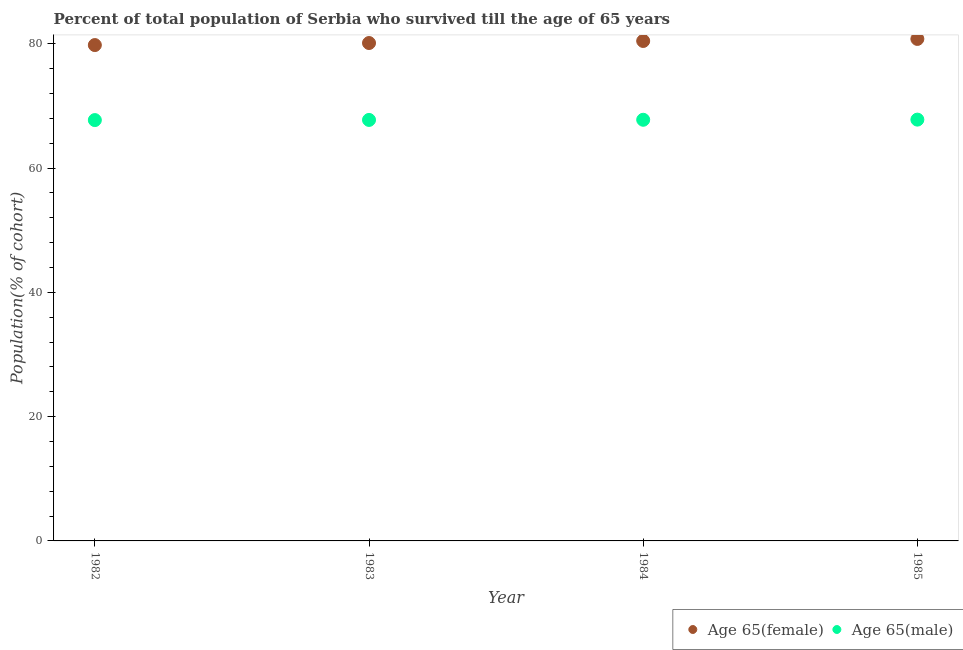What is the percentage of female population who survived till age of 65 in 1985?
Keep it short and to the point. 80.77. Across all years, what is the maximum percentage of male population who survived till age of 65?
Give a very brief answer. 67.79. Across all years, what is the minimum percentage of female population who survived till age of 65?
Your answer should be very brief. 79.78. What is the total percentage of male population who survived till age of 65 in the graph?
Your answer should be very brief. 271. What is the difference between the percentage of female population who survived till age of 65 in 1983 and that in 1985?
Offer a very short reply. -0.66. What is the difference between the percentage of female population who survived till age of 65 in 1982 and the percentage of male population who survived till age of 65 in 1984?
Ensure brevity in your answer.  12.02. What is the average percentage of female population who survived till age of 65 per year?
Provide a succinct answer. 80.27. In the year 1985, what is the difference between the percentage of male population who survived till age of 65 and percentage of female population who survived till age of 65?
Your answer should be very brief. -12.98. What is the ratio of the percentage of female population who survived till age of 65 in 1982 to that in 1983?
Make the answer very short. 1. Is the percentage of male population who survived till age of 65 in 1982 less than that in 1985?
Keep it short and to the point. Yes. What is the difference between the highest and the second highest percentage of male population who survived till age of 65?
Offer a terse response. 0.02. What is the difference between the highest and the lowest percentage of female population who survived till age of 65?
Give a very brief answer. 0.99. In how many years, is the percentage of male population who survived till age of 65 greater than the average percentage of male population who survived till age of 65 taken over all years?
Offer a very short reply. 2. Is the percentage of female population who survived till age of 65 strictly less than the percentage of male population who survived till age of 65 over the years?
Your response must be concise. No. What is the difference between two consecutive major ticks on the Y-axis?
Your answer should be compact. 20. Are the values on the major ticks of Y-axis written in scientific E-notation?
Provide a succinct answer. No. Does the graph contain grids?
Provide a succinct answer. No. Where does the legend appear in the graph?
Provide a short and direct response. Bottom right. How are the legend labels stacked?
Your response must be concise. Horizontal. What is the title of the graph?
Your answer should be very brief. Percent of total population of Serbia who survived till the age of 65 years. Does "Grants" appear as one of the legend labels in the graph?
Provide a short and direct response. No. What is the label or title of the Y-axis?
Ensure brevity in your answer.  Population(% of cohort). What is the Population(% of cohort) in Age 65(female) in 1982?
Keep it short and to the point. 79.78. What is the Population(% of cohort) of Age 65(male) in 1982?
Offer a terse response. 67.71. What is the Population(% of cohort) of Age 65(female) in 1983?
Provide a short and direct response. 80.11. What is the Population(% of cohort) of Age 65(male) in 1983?
Give a very brief answer. 67.74. What is the Population(% of cohort) of Age 65(female) in 1984?
Ensure brevity in your answer.  80.44. What is the Population(% of cohort) in Age 65(male) in 1984?
Your answer should be very brief. 67.76. What is the Population(% of cohort) of Age 65(female) in 1985?
Your response must be concise. 80.77. What is the Population(% of cohort) in Age 65(male) in 1985?
Provide a short and direct response. 67.79. Across all years, what is the maximum Population(% of cohort) of Age 65(female)?
Provide a succinct answer. 80.77. Across all years, what is the maximum Population(% of cohort) in Age 65(male)?
Provide a short and direct response. 67.79. Across all years, what is the minimum Population(% of cohort) in Age 65(female)?
Give a very brief answer. 79.78. Across all years, what is the minimum Population(% of cohort) in Age 65(male)?
Keep it short and to the point. 67.71. What is the total Population(% of cohort) of Age 65(female) in the graph?
Your response must be concise. 321.1. What is the total Population(% of cohort) of Age 65(male) in the graph?
Keep it short and to the point. 271. What is the difference between the Population(% of cohort) of Age 65(female) in 1982 and that in 1983?
Provide a short and direct response. -0.33. What is the difference between the Population(% of cohort) in Age 65(male) in 1982 and that in 1983?
Offer a terse response. -0.03. What is the difference between the Population(% of cohort) in Age 65(female) in 1982 and that in 1984?
Give a very brief answer. -0.66. What is the difference between the Population(% of cohort) of Age 65(male) in 1982 and that in 1984?
Make the answer very short. -0.05. What is the difference between the Population(% of cohort) in Age 65(female) in 1982 and that in 1985?
Keep it short and to the point. -0.99. What is the difference between the Population(% of cohort) of Age 65(male) in 1982 and that in 1985?
Your response must be concise. -0.07. What is the difference between the Population(% of cohort) of Age 65(female) in 1983 and that in 1984?
Offer a terse response. -0.33. What is the difference between the Population(% of cohort) of Age 65(male) in 1983 and that in 1984?
Ensure brevity in your answer.  -0.03. What is the difference between the Population(% of cohort) in Age 65(female) in 1983 and that in 1985?
Offer a very short reply. -0.66. What is the difference between the Population(% of cohort) of Age 65(female) in 1984 and that in 1985?
Ensure brevity in your answer.  -0.33. What is the difference between the Population(% of cohort) of Age 65(male) in 1984 and that in 1985?
Your answer should be compact. -0.03. What is the difference between the Population(% of cohort) in Age 65(female) in 1982 and the Population(% of cohort) in Age 65(male) in 1983?
Offer a terse response. 12.04. What is the difference between the Population(% of cohort) of Age 65(female) in 1982 and the Population(% of cohort) of Age 65(male) in 1984?
Your answer should be very brief. 12.02. What is the difference between the Population(% of cohort) of Age 65(female) in 1982 and the Population(% of cohort) of Age 65(male) in 1985?
Offer a terse response. 11.99. What is the difference between the Population(% of cohort) in Age 65(female) in 1983 and the Population(% of cohort) in Age 65(male) in 1984?
Your answer should be very brief. 12.35. What is the difference between the Population(% of cohort) of Age 65(female) in 1983 and the Population(% of cohort) of Age 65(male) in 1985?
Provide a short and direct response. 12.32. What is the difference between the Population(% of cohort) in Age 65(female) in 1984 and the Population(% of cohort) in Age 65(male) in 1985?
Keep it short and to the point. 12.65. What is the average Population(% of cohort) of Age 65(female) per year?
Your answer should be compact. 80.28. What is the average Population(% of cohort) of Age 65(male) per year?
Provide a short and direct response. 67.75. In the year 1982, what is the difference between the Population(% of cohort) in Age 65(female) and Population(% of cohort) in Age 65(male)?
Provide a short and direct response. 12.07. In the year 1983, what is the difference between the Population(% of cohort) of Age 65(female) and Population(% of cohort) of Age 65(male)?
Offer a very short reply. 12.37. In the year 1984, what is the difference between the Population(% of cohort) in Age 65(female) and Population(% of cohort) in Age 65(male)?
Offer a terse response. 12.68. In the year 1985, what is the difference between the Population(% of cohort) of Age 65(female) and Population(% of cohort) of Age 65(male)?
Your answer should be compact. 12.98. What is the ratio of the Population(% of cohort) in Age 65(female) in 1982 to that in 1983?
Keep it short and to the point. 1. What is the ratio of the Population(% of cohort) in Age 65(male) in 1982 to that in 1984?
Keep it short and to the point. 1. What is the ratio of the Population(% of cohort) in Age 65(female) in 1982 to that in 1985?
Your answer should be compact. 0.99. What is the ratio of the Population(% of cohort) in Age 65(male) in 1982 to that in 1985?
Your response must be concise. 1. What is the ratio of the Population(% of cohort) of Age 65(female) in 1983 to that in 1984?
Your response must be concise. 1. What is the ratio of the Population(% of cohort) of Age 65(female) in 1983 to that in 1985?
Your answer should be very brief. 0.99. What is the ratio of the Population(% of cohort) of Age 65(female) in 1984 to that in 1985?
Your answer should be very brief. 1. What is the difference between the highest and the second highest Population(% of cohort) in Age 65(female)?
Your response must be concise. 0.33. What is the difference between the highest and the second highest Population(% of cohort) in Age 65(male)?
Make the answer very short. 0.03. What is the difference between the highest and the lowest Population(% of cohort) in Age 65(female)?
Your answer should be compact. 0.99. What is the difference between the highest and the lowest Population(% of cohort) of Age 65(male)?
Make the answer very short. 0.07. 